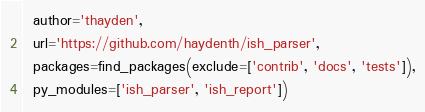Convert code to text. <code><loc_0><loc_0><loc_500><loc_500><_Python_>  author='thayden',
  url='https://github.com/haydenth/ish_parser',
  packages=find_packages(exclude=['contrib', 'docs', 'tests']),
  py_modules=['ish_parser', 'ish_report'])
</code> 